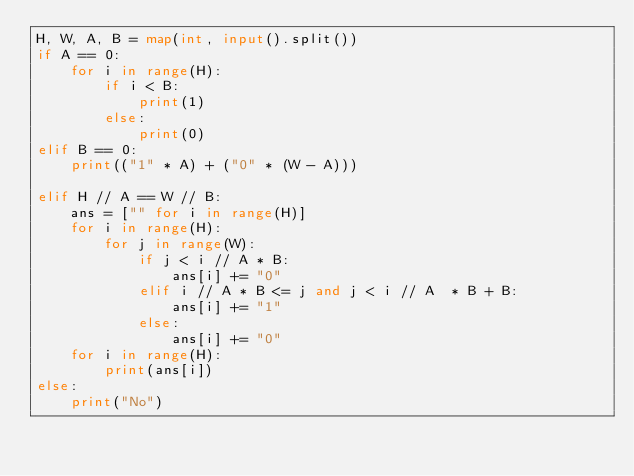Convert code to text. <code><loc_0><loc_0><loc_500><loc_500><_Python_>H, W, A, B = map(int, input().split())
if A == 0:
    for i in range(H):
        if i < B:
            print(1)
        else:
            print(0)
elif B == 0:
    print(("1" * A) + ("0" * (W - A)))
    
elif H // A == W // B:
    ans = ["" for i in range(H)]
    for i in range(H):
        for j in range(W):
            if j < i // A * B:
                ans[i] += "0"
            elif i // A * B <= j and j < i // A  * B + B:
                ans[i] += "1"
            else:
                ans[i] += "0"
    for i in range(H):
        print(ans[i])
else:
    print("No")</code> 